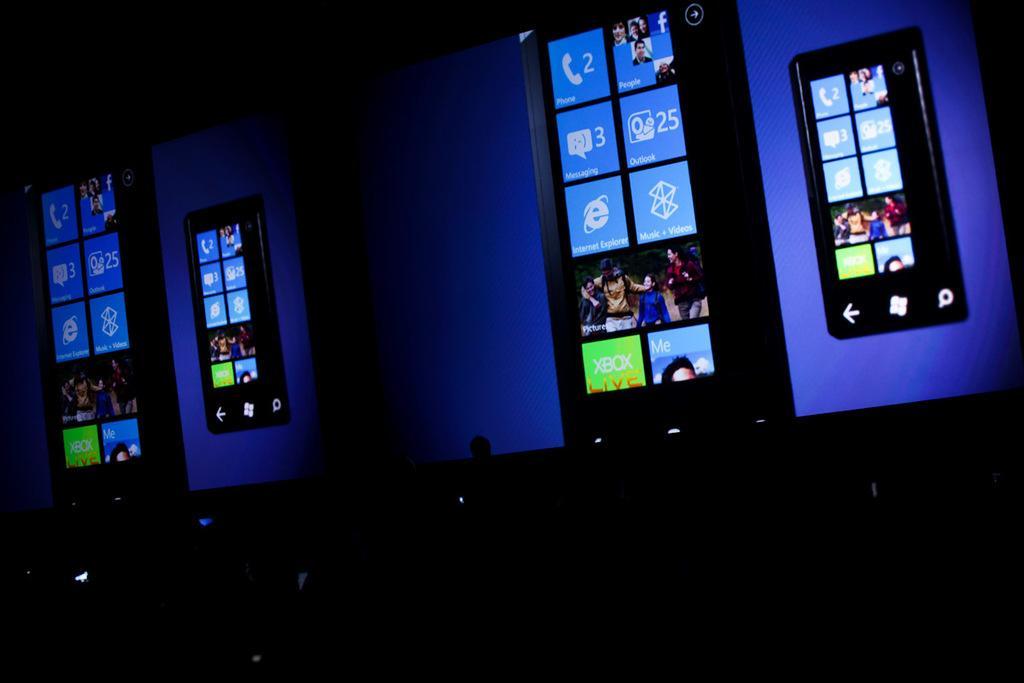Can you describe this image briefly? This is a dark picture, we can see some screens and there is a blue color light background. 